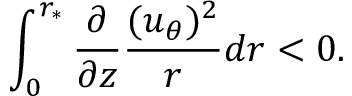<formula> <loc_0><loc_0><loc_500><loc_500>\int _ { 0 } ^ { r _ { \ast } } \frac { \partial } { \partial z } \frac { ( u _ { \theta } ) ^ { 2 } } { r } d r < 0 .</formula> 